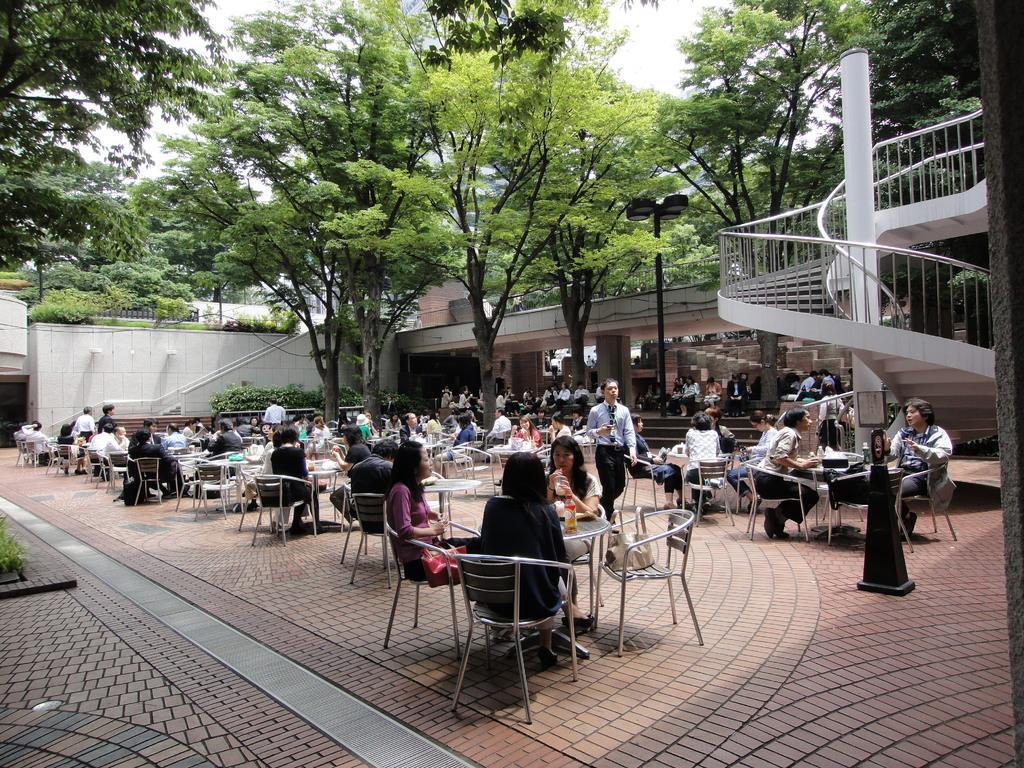Could you give a brief overview of what you see in this image? This picture shows an open area where people seated on the chairs and we see a person walking and few trees around and we see a stairs 